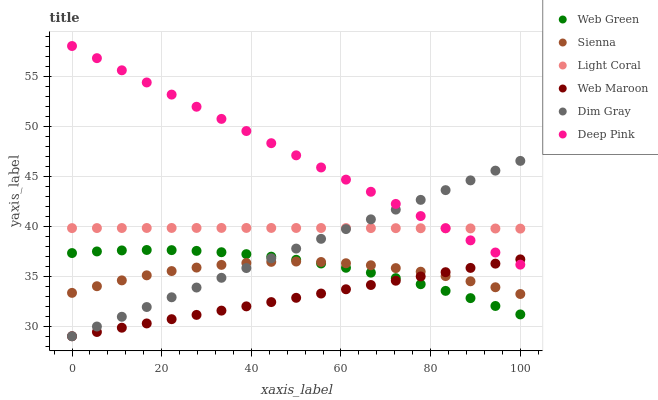Does Web Maroon have the minimum area under the curve?
Answer yes or no. Yes. Does Deep Pink have the maximum area under the curve?
Answer yes or no. Yes. Does Dim Gray have the minimum area under the curve?
Answer yes or no. No. Does Dim Gray have the maximum area under the curve?
Answer yes or no. No. Is Web Maroon the smoothest?
Answer yes or no. Yes. Is Sienna the roughest?
Answer yes or no. Yes. Is Dim Gray the smoothest?
Answer yes or no. No. Is Dim Gray the roughest?
Answer yes or no. No. Does Dim Gray have the lowest value?
Answer yes or no. Yes. Does Web Green have the lowest value?
Answer yes or no. No. Does Deep Pink have the highest value?
Answer yes or no. Yes. Does Dim Gray have the highest value?
Answer yes or no. No. Is Web Green less than Light Coral?
Answer yes or no. Yes. Is Deep Pink greater than Sienna?
Answer yes or no. Yes. Does Sienna intersect Dim Gray?
Answer yes or no. Yes. Is Sienna less than Dim Gray?
Answer yes or no. No. Is Sienna greater than Dim Gray?
Answer yes or no. No. Does Web Green intersect Light Coral?
Answer yes or no. No. 